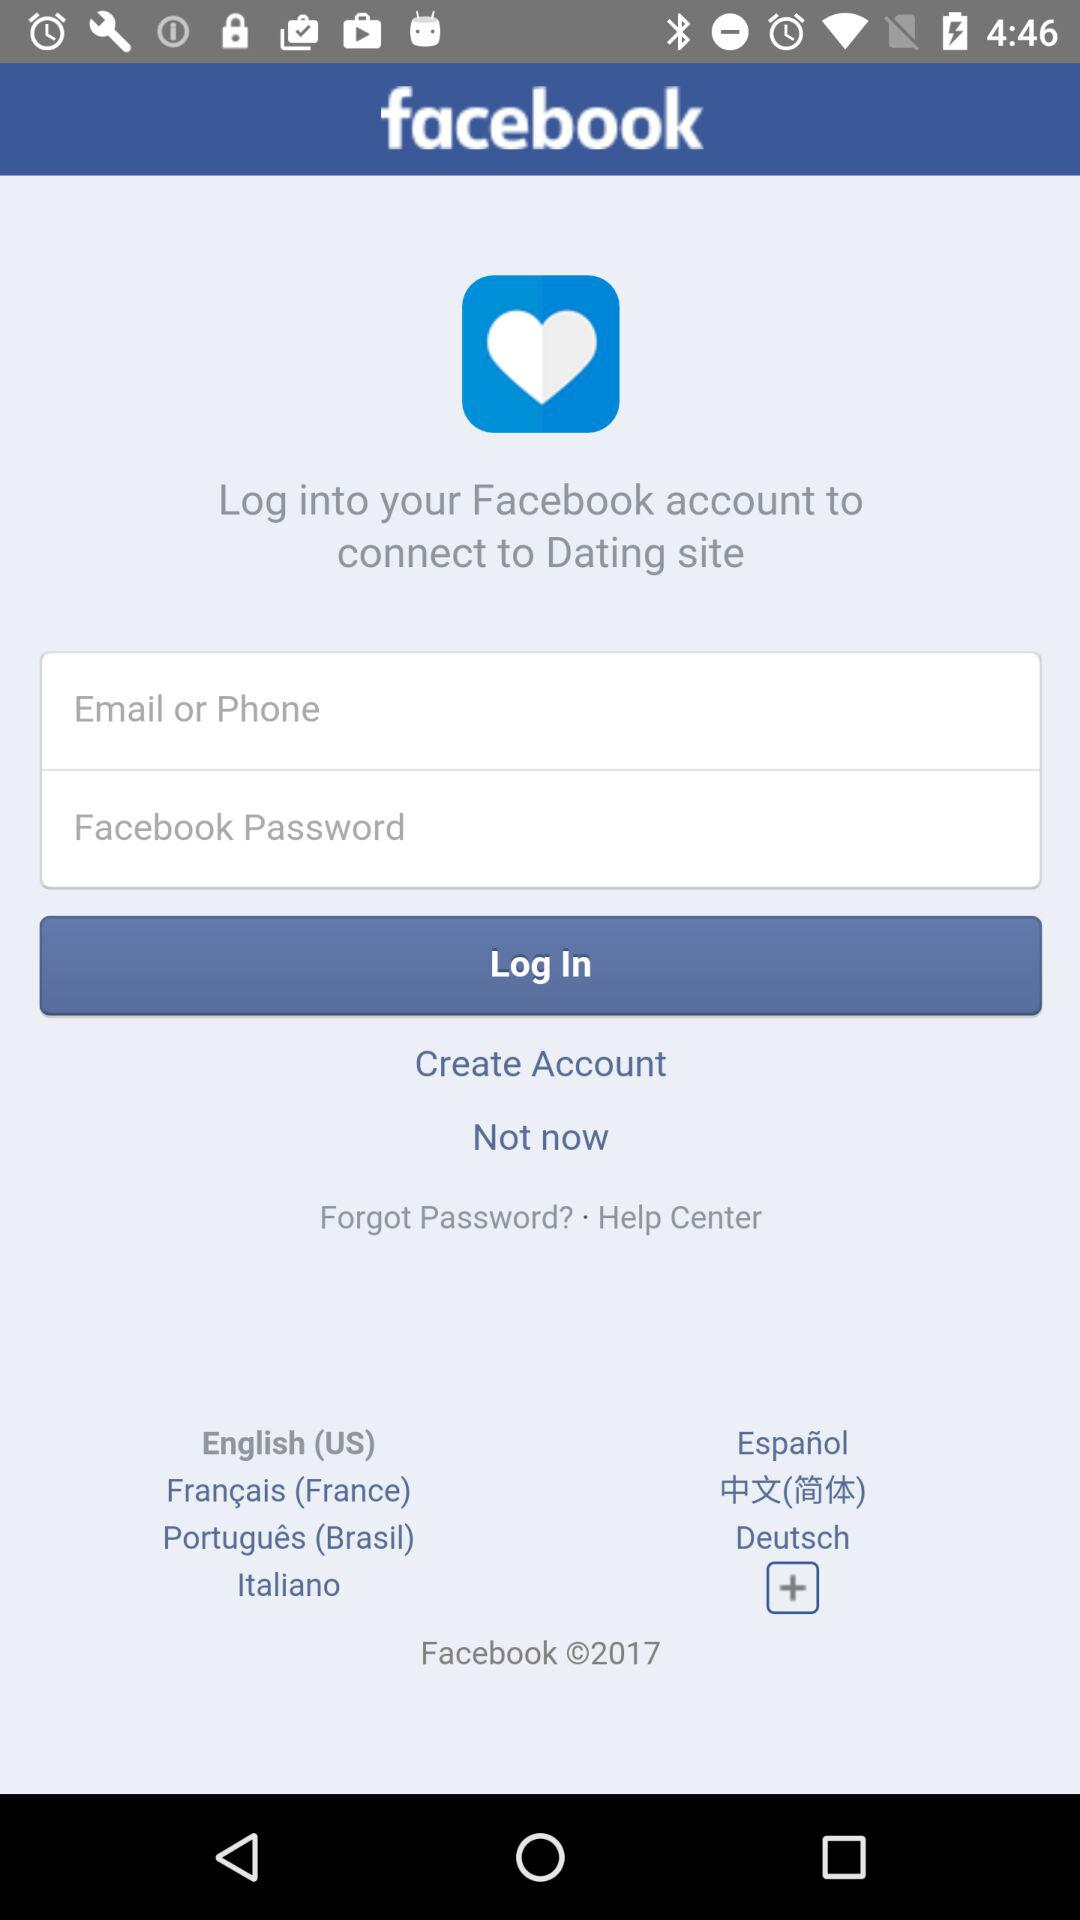Through what application can we log in to connect to the Dating site? You can log in through "Facebook" to connect to the Dating site. 